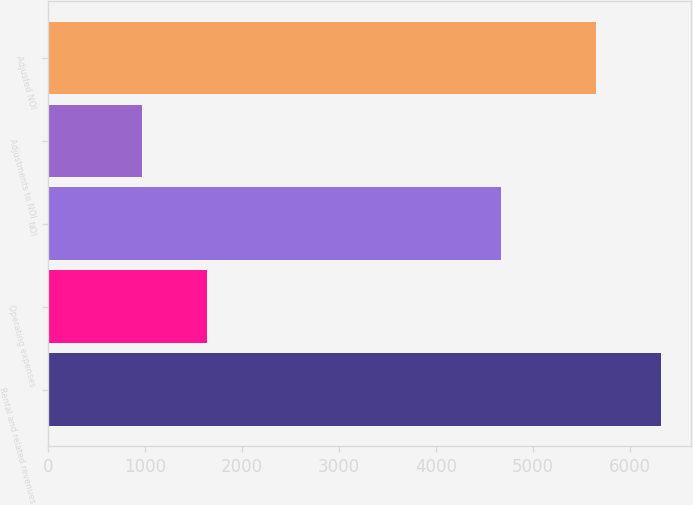Convert chart. <chart><loc_0><loc_0><loc_500><loc_500><bar_chart><fcel>Rental and related revenues<fcel>Operating expenses<fcel>NOI<fcel>Adjustments to NOI<fcel>Adjusted NOI<nl><fcel>6316<fcel>1641<fcel>4675<fcel>972<fcel>5647<nl></chart> 